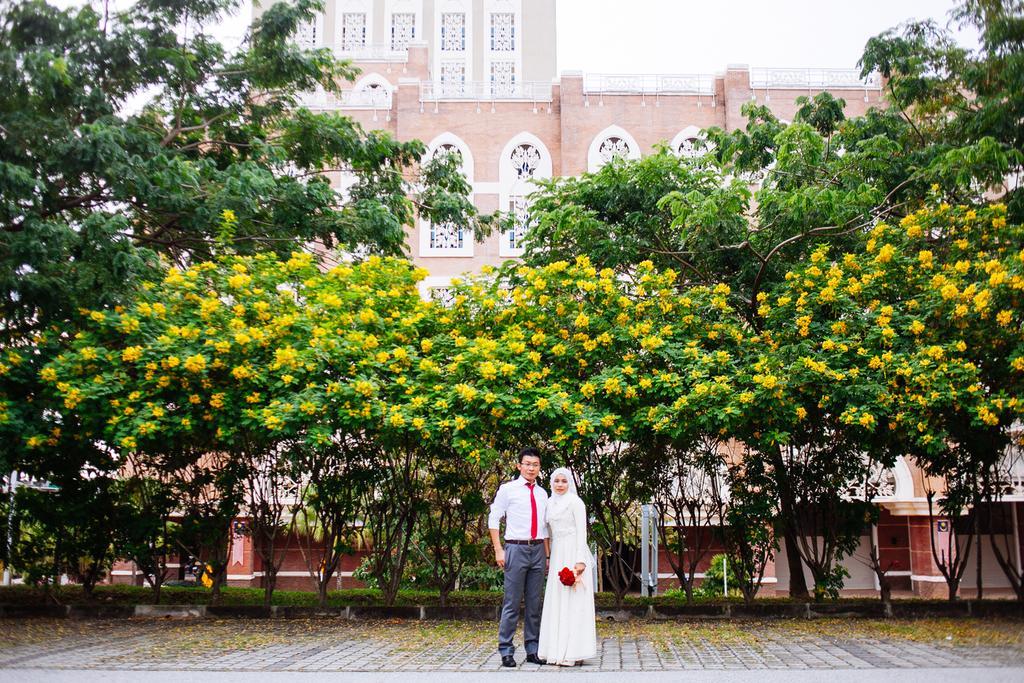Can you describe this image briefly? In the background we can see a building. We can see the wall, trees, grass and objects. In this picture we can see a man and a woman standing on the pathway. We can see a woman holding flowers. 